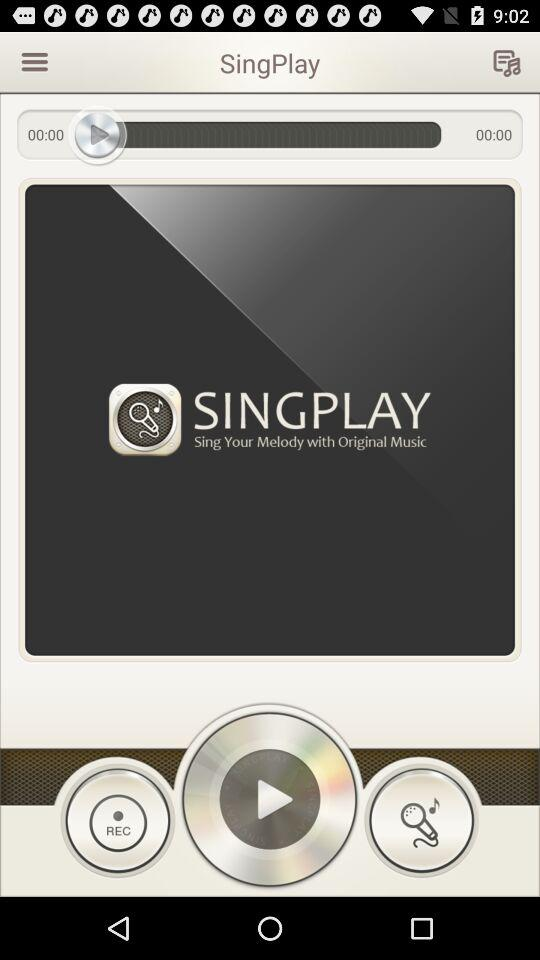What is the name of the application? The name of the application is "SingPlay". 